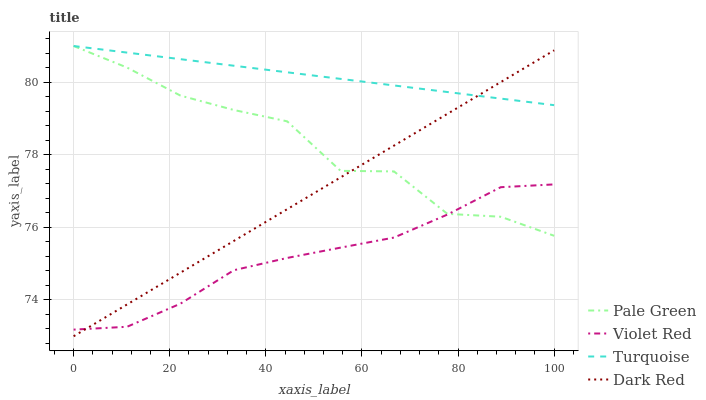Does Violet Red have the minimum area under the curve?
Answer yes or no. Yes. Does Turquoise have the maximum area under the curve?
Answer yes or no. Yes. Does Pale Green have the minimum area under the curve?
Answer yes or no. No. Does Pale Green have the maximum area under the curve?
Answer yes or no. No. Is Turquoise the smoothest?
Answer yes or no. Yes. Is Pale Green the roughest?
Answer yes or no. Yes. Is Violet Red the smoothest?
Answer yes or no. No. Is Violet Red the roughest?
Answer yes or no. No. Does Violet Red have the lowest value?
Answer yes or no. No. Does Turquoise have the highest value?
Answer yes or no. Yes. Does Violet Red have the highest value?
Answer yes or no. No. Is Violet Red less than Turquoise?
Answer yes or no. Yes. Is Turquoise greater than Violet Red?
Answer yes or no. Yes. Does Violet Red intersect Pale Green?
Answer yes or no. Yes. Is Violet Red less than Pale Green?
Answer yes or no. No. Is Violet Red greater than Pale Green?
Answer yes or no. No. Does Violet Red intersect Turquoise?
Answer yes or no. No. 